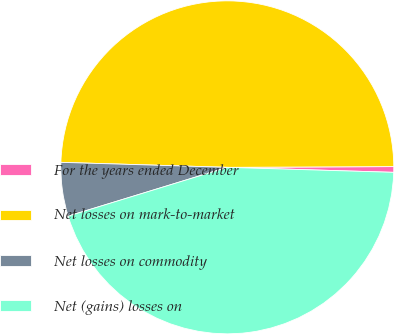<chart> <loc_0><loc_0><loc_500><loc_500><pie_chart><fcel>For the years ended December<fcel>Net losses on mark-to-market<fcel>Net losses on commodity<fcel>Net (gains) losses on<nl><fcel>0.55%<fcel>49.45%<fcel>5.21%<fcel>44.79%<nl></chart> 